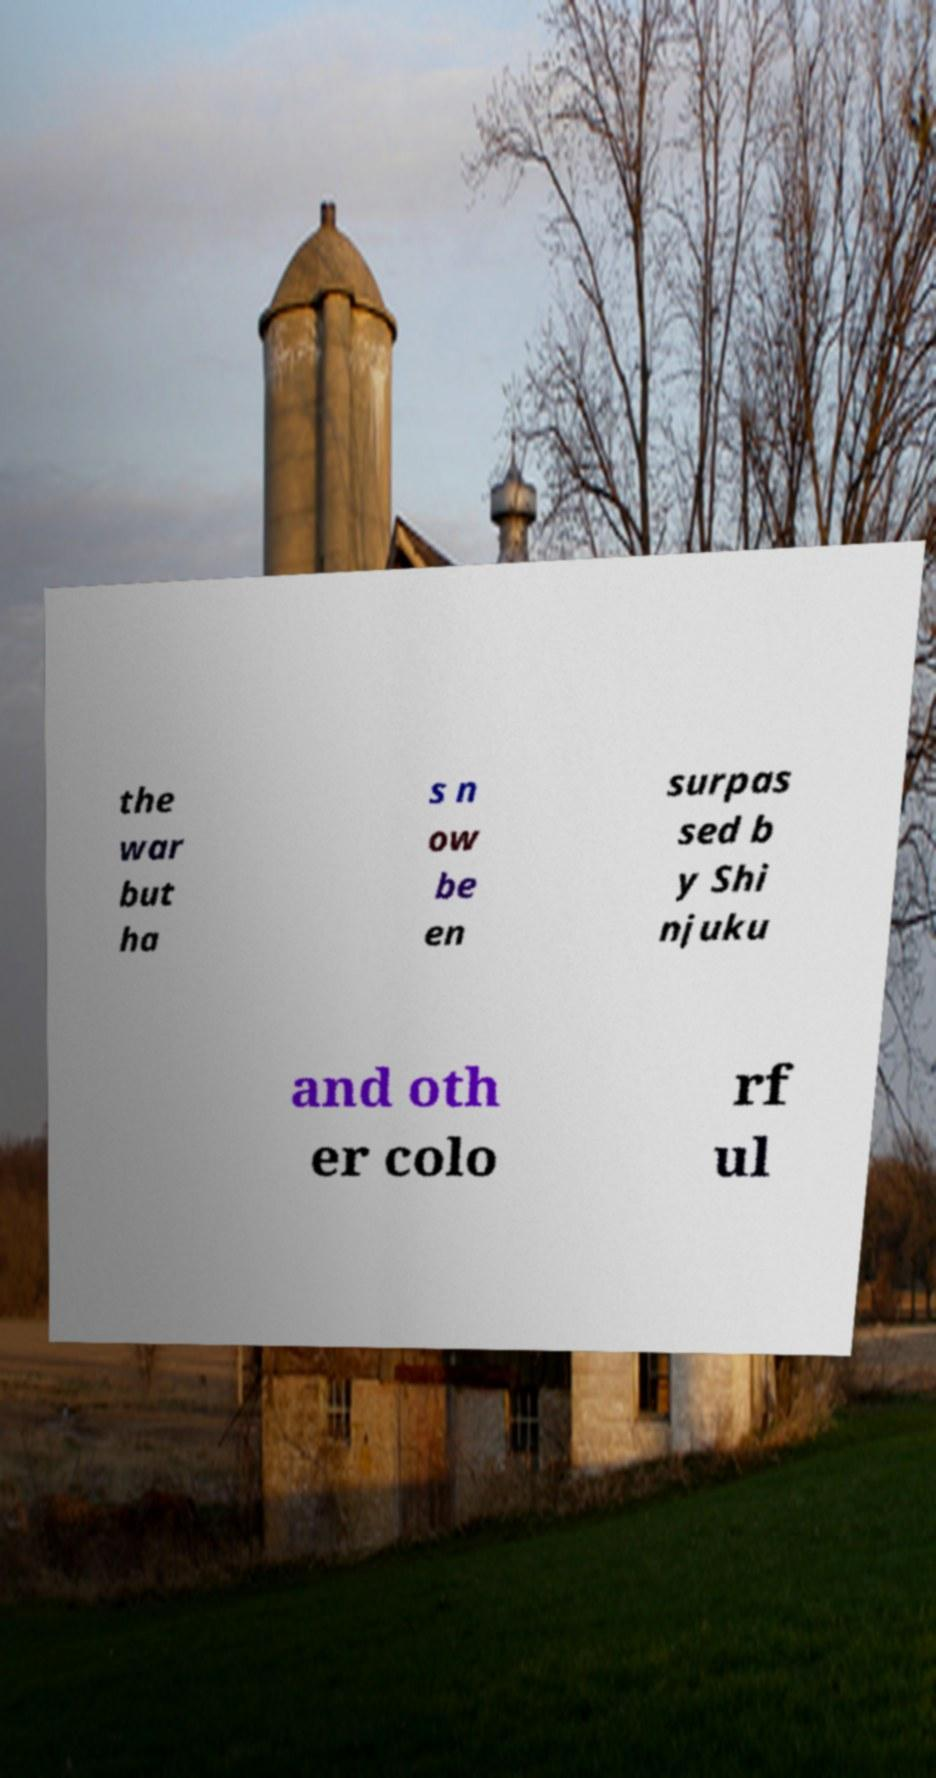What messages or text are displayed in this image? I need them in a readable, typed format. the war but ha s n ow be en surpas sed b y Shi njuku and oth er colo rf ul 